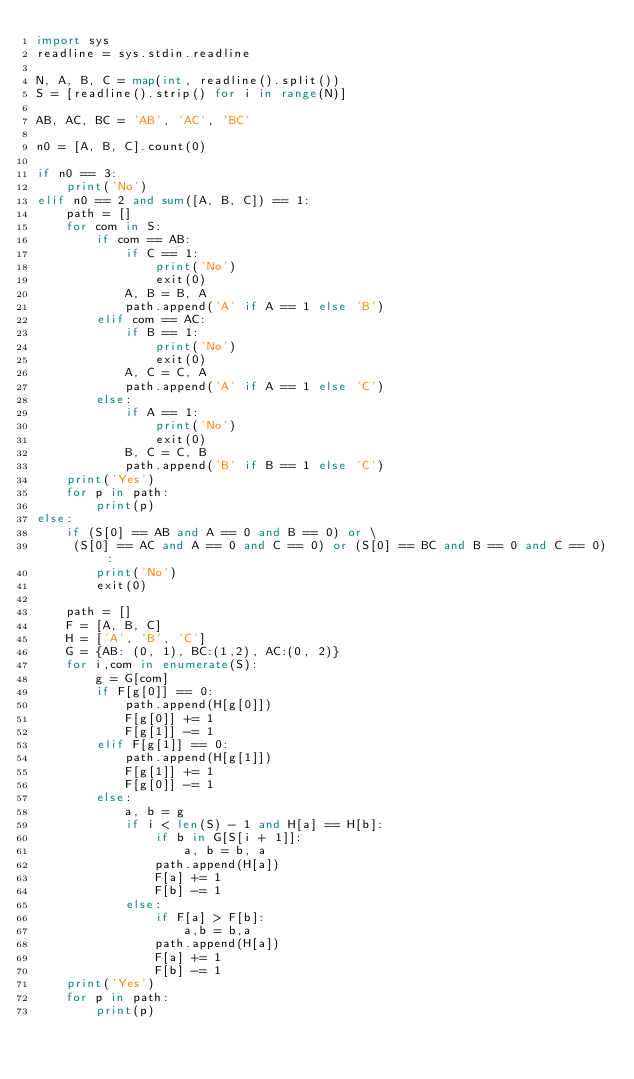Convert code to text. <code><loc_0><loc_0><loc_500><loc_500><_Python_>import sys
readline = sys.stdin.readline

N, A, B, C = map(int, readline().split())
S = [readline().strip() for i in range(N)]

AB, AC, BC = 'AB', 'AC', 'BC'

n0 = [A, B, C].count(0)

if n0 == 3:
    print('No')
elif n0 == 2 and sum([A, B, C]) == 1:
    path = []
    for com in S:
        if com == AB:
            if C == 1:
                print('No')
                exit(0)
            A, B = B, A
            path.append('A' if A == 1 else 'B')
        elif com == AC:
            if B == 1:
                print('No')
                exit(0)
            A, C = C, A
            path.append('A' if A == 1 else 'C')
        else:
            if A == 1:
                print('No')
                exit(0)
            B, C = C, B
            path.append('B' if B == 1 else 'C')
    print('Yes')
    for p in path:
        print(p)
else:
    if (S[0] == AB and A == 0 and B == 0) or \
     (S[0] == AC and A == 0 and C == 0) or (S[0] == BC and B == 0 and C == 0):
        print('No')
        exit(0)

    path = []
    F = [A, B, C]
    H = ['A', 'B', 'C']
    G = {AB: (0, 1), BC:(1,2), AC:(0, 2)}
    for i,com in enumerate(S):
        g = G[com]
        if F[g[0]] == 0:
            path.append(H[g[0]])
            F[g[0]] += 1
            F[g[1]] -= 1
        elif F[g[1]] == 0:
            path.append(H[g[1]])
            F[g[1]] += 1
            F[g[0]] -= 1
        else:
            a, b = g
            if i < len(S) - 1 and H[a] == H[b]:
                if b in G[S[i + 1]]:
                    a, b = b, a
                path.append(H[a])
                F[a] += 1
                F[b] -= 1
            else:
                if F[a] > F[b]:
                    a,b = b,a
                path.append(H[a])
                F[a] += 1
                F[b] -= 1
    print('Yes')
    for p in path:
        print(p)
                


</code> 